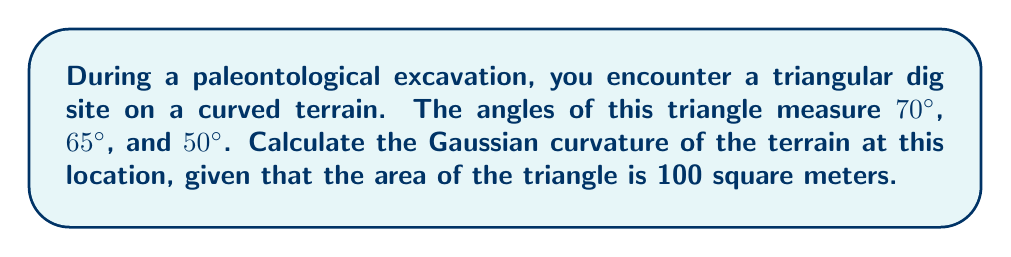Can you solve this math problem? Let's approach this step-by-step:

1) In non-Euclidean geometry, the sum of angles in a triangle is not always 180°. The difference from 180° is related to the curvature of the surface.

2) Let's calculate the sum of the angles in our triangle:
   $70° + 65° + 50° = 185°$

3) The excess angle $\epsilon$ is the difference between this sum and 180°:
   $\epsilon = 185° - 180° = 5°$

4) The Gaussian curvature $K$ is related to the excess angle $\epsilon$ and the area $A$ of the triangle by the formula:

   $$K = \frac{\epsilon}{A}$$

   Where $\epsilon$ is in radians and $A$ is in square meters.

5) We need to convert 5° to radians:
   $5° \times \frac{\pi}{180°} = \frac{\pi}{36}$ radians

6) Now we can substitute into our formula:

   $$K = \frac{\frac{\pi}{36}}{100} = \frac{\pi}{3600} \approx 0.000873$$

So, the Gaussian curvature of the terrain at this location is $\frac{\pi}{3600}$ per square meter.
Answer: $\frac{\pi}{3600}$ m$^{-2}$ 